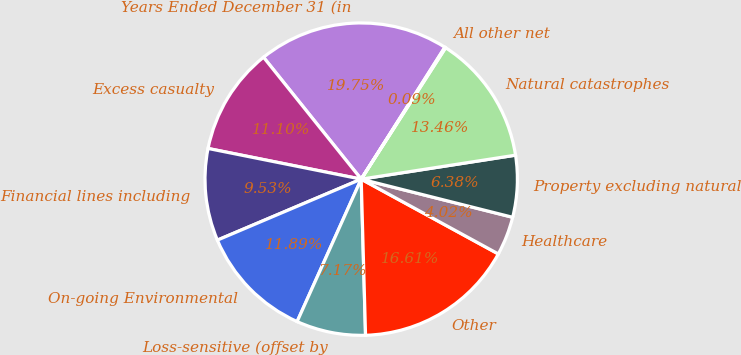Convert chart to OTSL. <chart><loc_0><loc_0><loc_500><loc_500><pie_chart><fcel>Years Ended December 31 (in<fcel>Excess casualty<fcel>Financial lines including<fcel>On-going Environmental<fcel>Loss-sensitive (offset by<fcel>Other<fcel>Healthcare<fcel>Property excluding natural<fcel>Natural catastrophes<fcel>All other net<nl><fcel>19.75%<fcel>11.1%<fcel>9.53%<fcel>11.89%<fcel>7.17%<fcel>16.61%<fcel>4.02%<fcel>6.38%<fcel>13.46%<fcel>0.09%<nl></chart> 